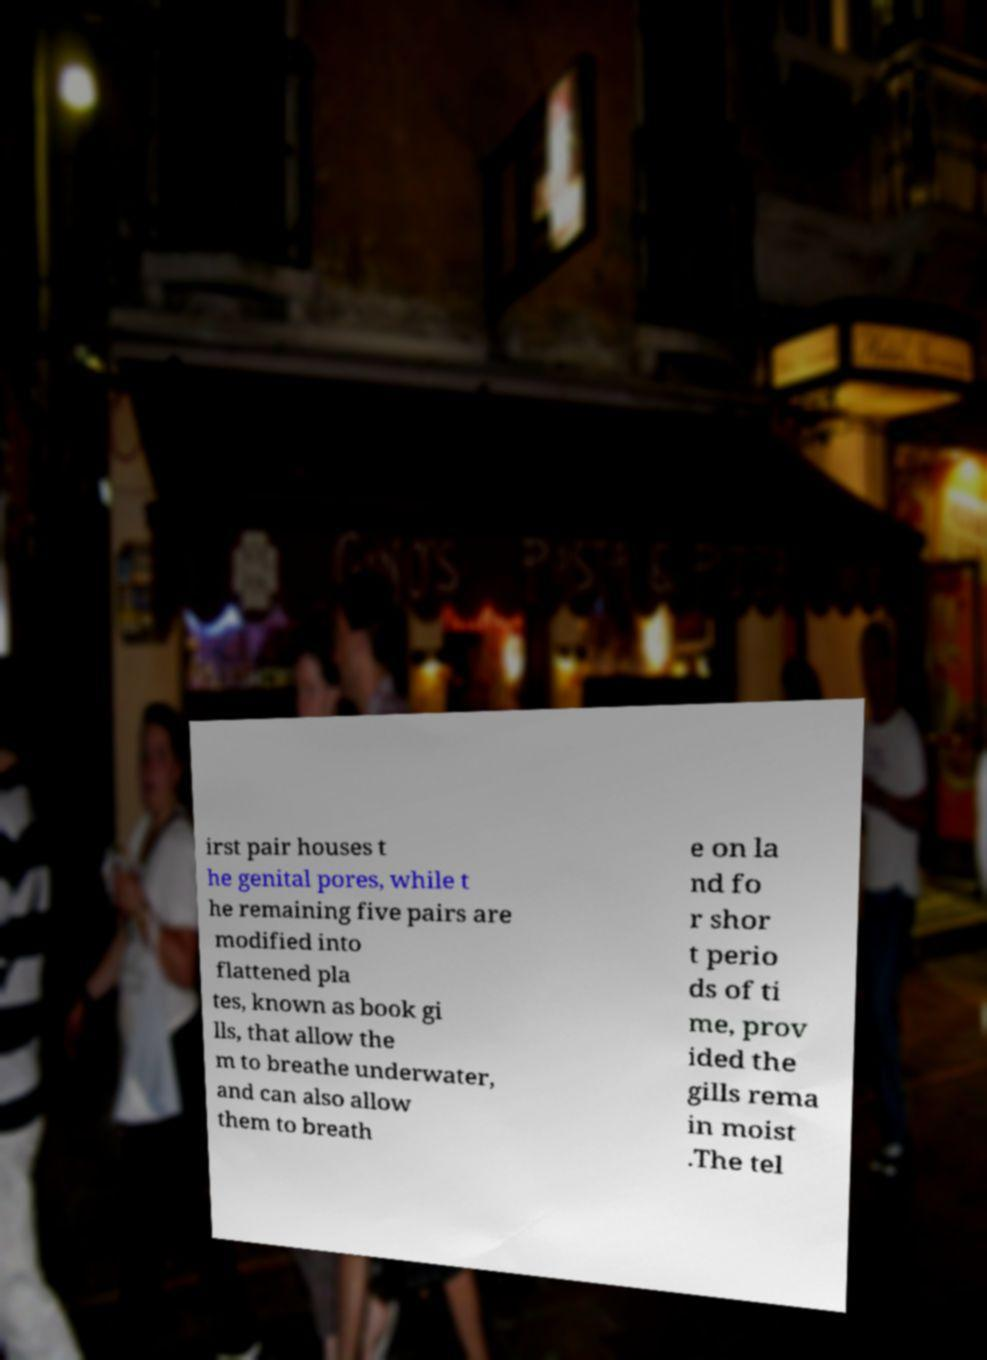Could you extract and type out the text from this image? irst pair houses t he genital pores, while t he remaining five pairs are modified into flattened pla tes, known as book gi lls, that allow the m to breathe underwater, and can also allow them to breath e on la nd fo r shor t perio ds of ti me, prov ided the gills rema in moist .The tel 